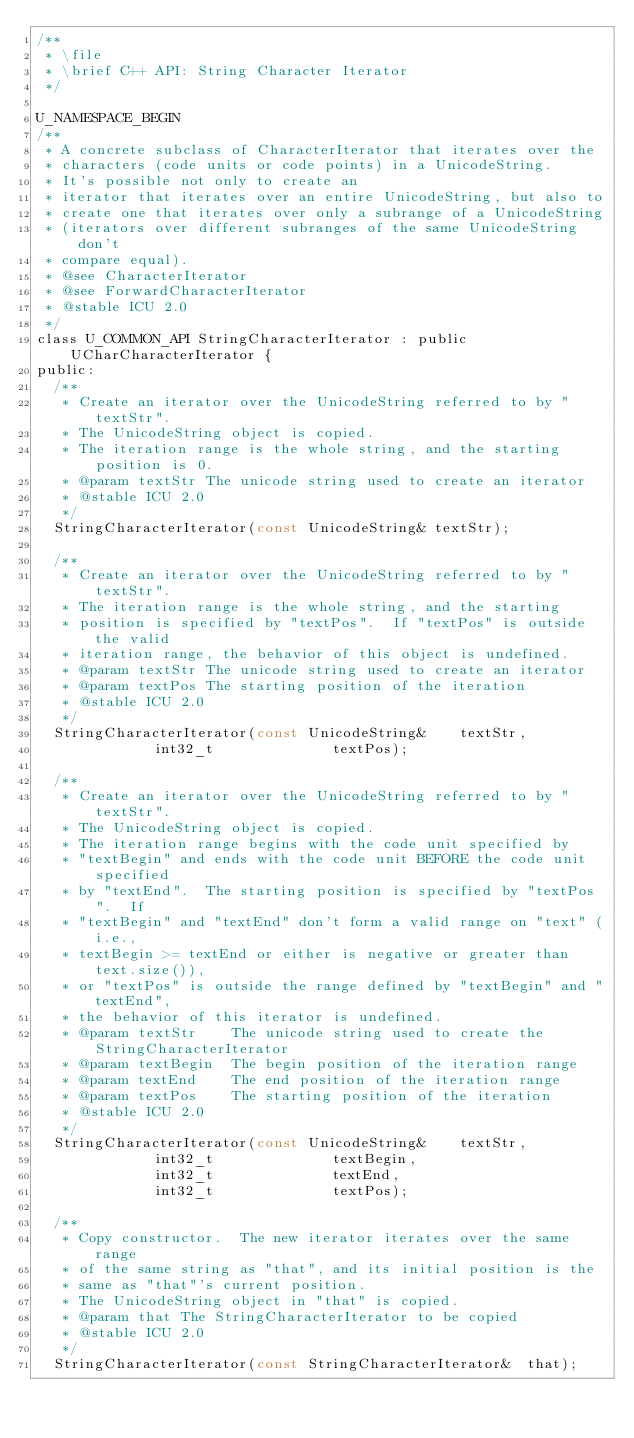<code> <loc_0><loc_0><loc_500><loc_500><_C_>/**
 * \file 
 * \brief C++ API: String Character Iterator
 */
 
U_NAMESPACE_BEGIN
/**
 * A concrete subclass of CharacterIterator that iterates over the
 * characters (code units or code points) in a UnicodeString.
 * It's possible not only to create an
 * iterator that iterates over an entire UnicodeString, but also to
 * create one that iterates over only a subrange of a UnicodeString
 * (iterators over different subranges of the same UnicodeString don't
 * compare equal).
 * @see CharacterIterator
 * @see ForwardCharacterIterator
 * @stable ICU 2.0
 */
class U_COMMON_API StringCharacterIterator : public UCharCharacterIterator {
public:
  /**
   * Create an iterator over the UnicodeString referred to by "textStr".
   * The UnicodeString object is copied.
   * The iteration range is the whole string, and the starting position is 0.
   * @param textStr The unicode string used to create an iterator
   * @stable ICU 2.0
   */
  StringCharacterIterator(const UnicodeString& textStr);

  /**
   * Create an iterator over the UnicodeString referred to by "textStr".
   * The iteration range is the whole string, and the starting
   * position is specified by "textPos".  If "textPos" is outside the valid
   * iteration range, the behavior of this object is undefined.
   * @param textStr The unicode string used to create an iterator
   * @param textPos The starting position of the iteration
   * @stable ICU 2.0
   */
  StringCharacterIterator(const UnicodeString&    textStr,
              int32_t              textPos);

  /**
   * Create an iterator over the UnicodeString referred to by "textStr".
   * The UnicodeString object is copied.
   * The iteration range begins with the code unit specified by
   * "textBegin" and ends with the code unit BEFORE the code unit specified
   * by "textEnd".  The starting position is specified by "textPos".  If
   * "textBegin" and "textEnd" don't form a valid range on "text" (i.e.,
   * textBegin >= textEnd or either is negative or greater than text.size()),
   * or "textPos" is outside the range defined by "textBegin" and "textEnd",
   * the behavior of this iterator is undefined.
   * @param textStr    The unicode string used to create the StringCharacterIterator
   * @param textBegin  The begin position of the iteration range
   * @param textEnd    The end position of the iteration range
   * @param textPos    The starting position of the iteration
   * @stable ICU 2.0
   */
  StringCharacterIterator(const UnicodeString&    textStr,
              int32_t              textBegin,
              int32_t              textEnd,
              int32_t              textPos);

  /**
   * Copy constructor.  The new iterator iterates over the same range
   * of the same string as "that", and its initial position is the
   * same as "that"'s current position.
   * The UnicodeString object in "that" is copied.
   * @param that The StringCharacterIterator to be copied
   * @stable ICU 2.0
   */
  StringCharacterIterator(const StringCharacterIterator&  that);
</code> 